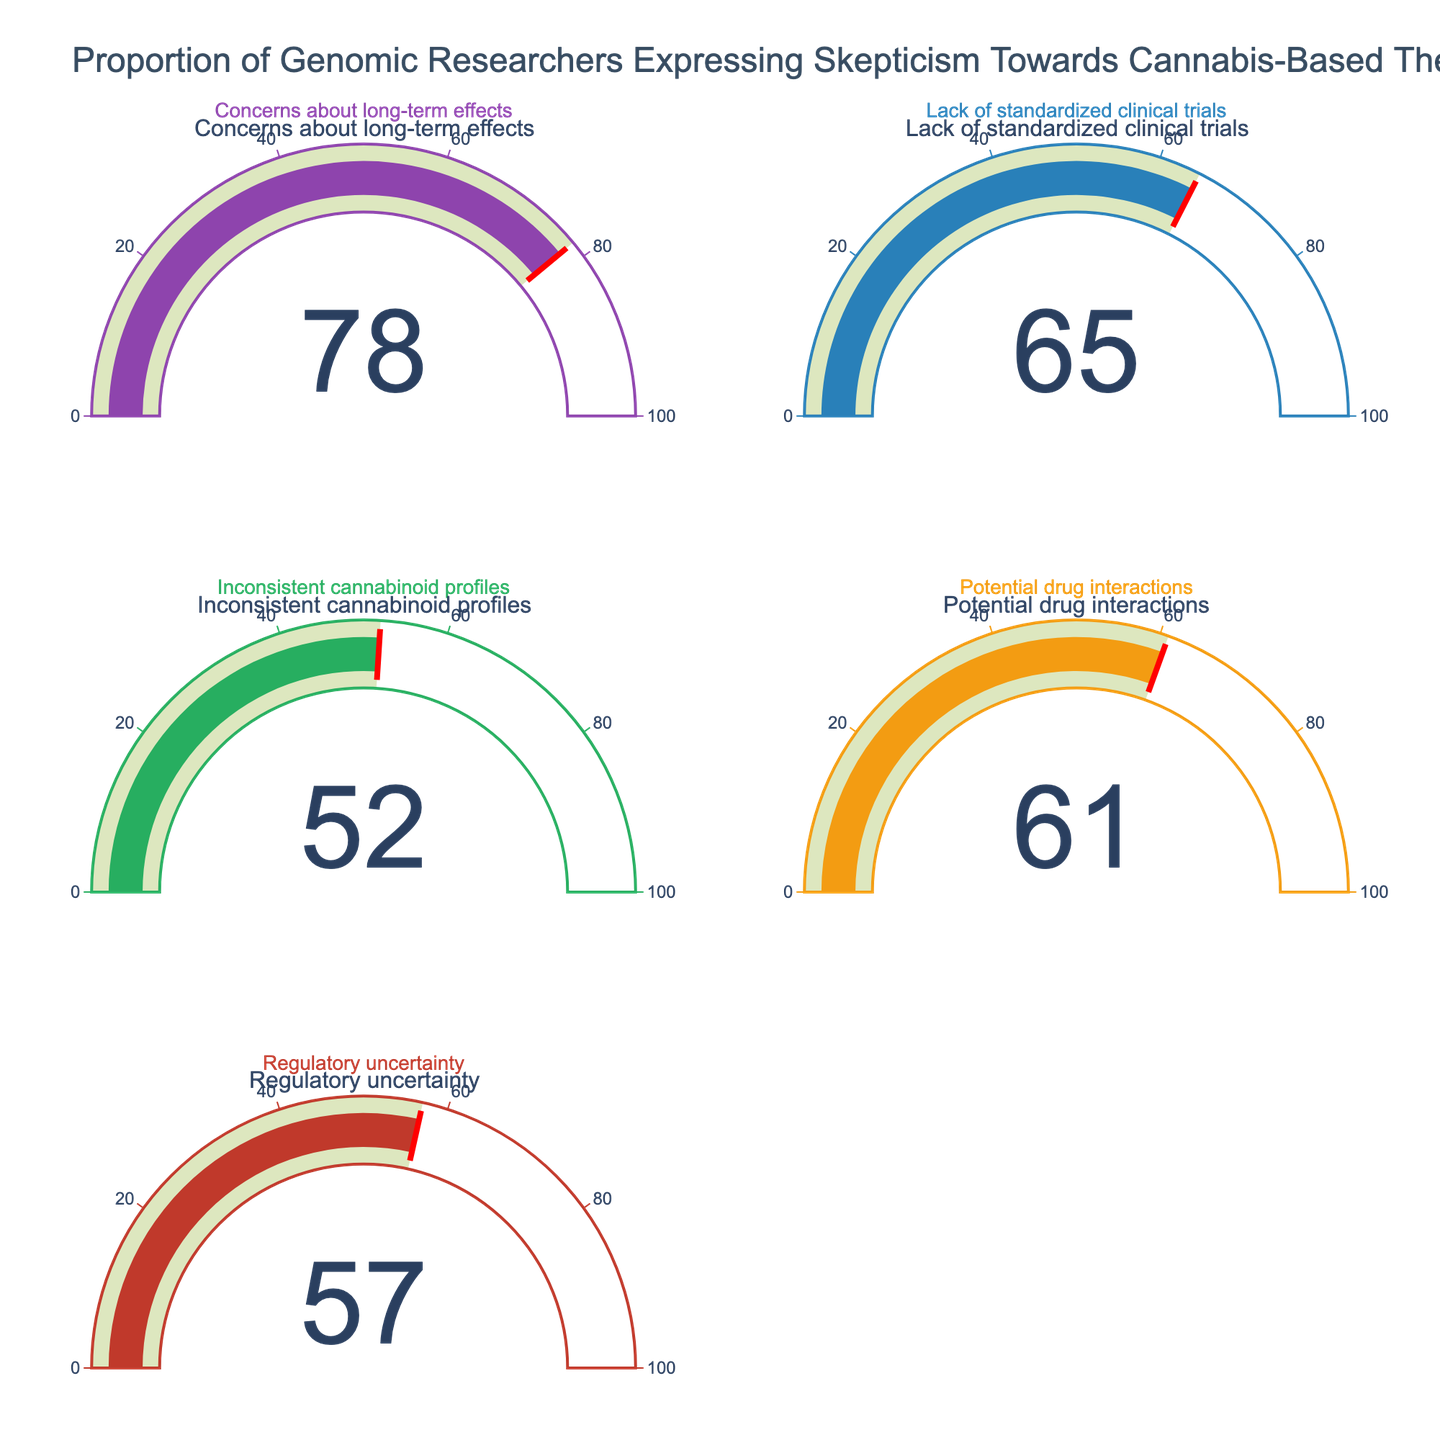What's the highest percentage of skepticism observed towards cannabis-based therapies? By looking at the gauge charts, identify the highest displayed percentage.
Answer: 78% Which concern has a higher percentage, Regulatory uncertainty or Potential drug interactions? Compare the percentages shown for Regulatory uncertainty (57%) and Potential drug interactions (61%).
Answer: Potential drug interactions What's the difference in the percentage between Concerns about long-term effects and Inconsistent cannabinoid profiles? Subtract the percentage of Inconsistent cannabinoid profiles (52%) from Concerns about long-term effects (78%).
Answer: 26% What is the median percentage of the skepticism concerns? Arrange the percentages in ascending order (52, 57, 61, 65, 78) and identify the middle value.
Answer: 61% How many skepticism concerns have a percentage above 60%? Count the gauge charts that show a percentage above 60 (78, 65, 61).
Answer: 3 What's the average percentage of all skepticism concerns? Sum all percentages (78 + 65 + 52 + 61 + 57 = 313) and divide by the number of concerns (5).
Answer: 62.6% Does the concern about Lack of standardized clinical trials have a percentage closer to Concerns about long-term effects or Inconsistent cannabinoid profiles? Compare the differences: 78 - 65 = 13 and 65 - 52 = 13. Both differences are equal.
Answer: Both equally close 